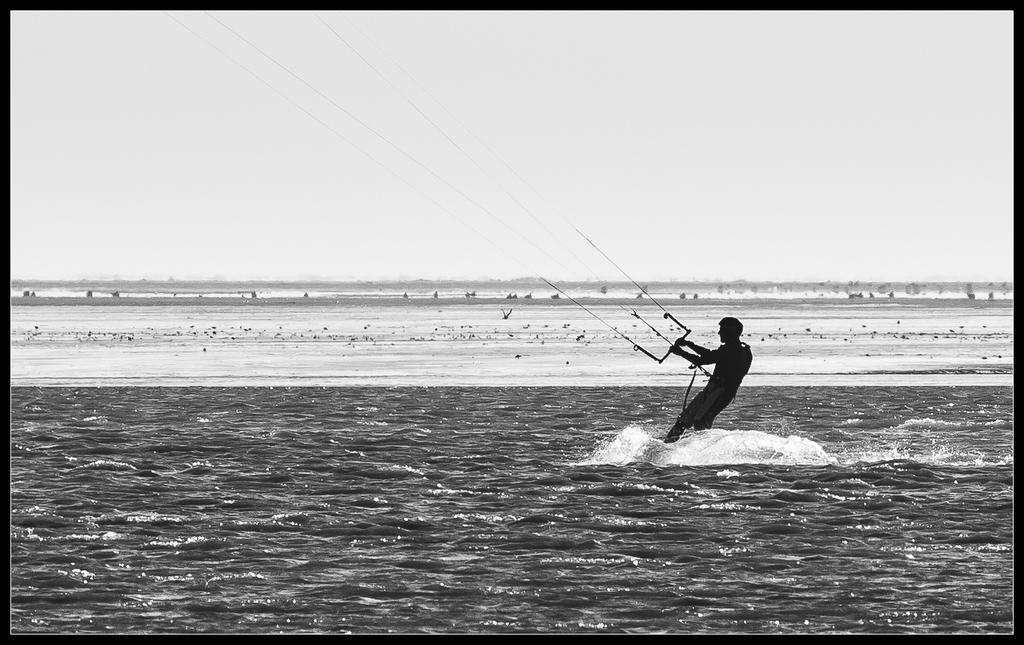What activity is the person in the image engaged in? The person is kitesurfing in the image. Where is the person performing this activity? The person is on the water. What can be seen in the background of the image? The sky is visible in the image. How would you describe the weather based on the appearance of the sky? The sky appears to be cloudy. How many girls are holding a pot in the image? There are no girls or pots present in the image; it features a person kitesurfing on the water with a cloudy sky in the background. 